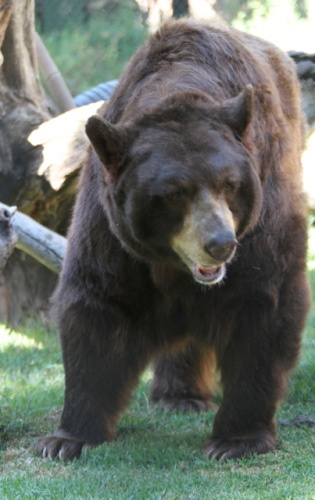Describe the objects in this image and their specific colors. I can see a bear in gray, black, and darkgray tones in this image. 